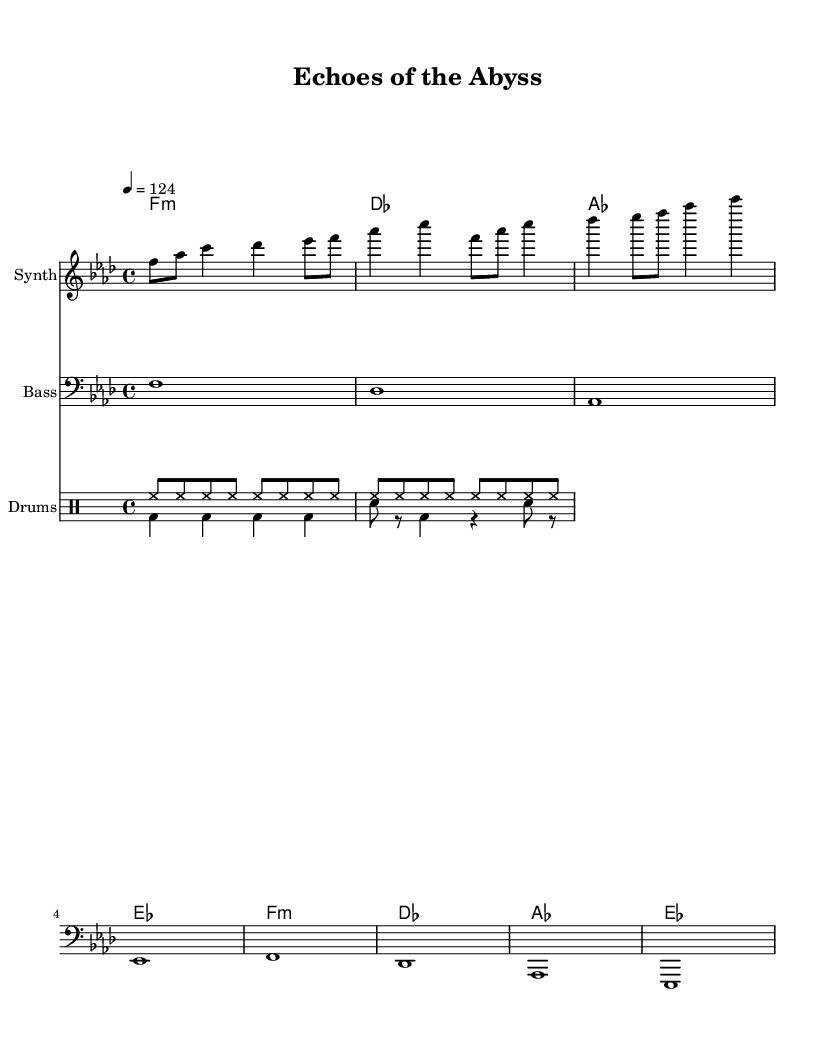What is the key signature of this music? The key signature is indicated by the notes shown at the beginning of the staff. In this case, it shows four flats, which corresponds to F minor.
Answer: F minor What is the tempo marking of this piece? The tempo is indicated at the beginning of the score as "4 = 124", which means that the quarter note gets a tempo of 124 beats per minute.
Answer: 124 How many measures are in the melody section? The melody section consists of two identical lines, each containing four beats. Therefore, there are two measures in total.
Answer: 2 What chord is played in the first measure? The first measure of the harmony shows F minor chord which is represented using the appropriate chord symbols.
Answer: F minor What rhythmic pattern is used for the hi-hat in the drum section? The hi-hat pattern is indicated in the drum section and consists of continuous eighth notes throughout the two measures.
Answer: Eighth notes How many different instruments are represented in the score? The score shows three distinct parts: the synth for the melody, the bass, and the drums. Altogether, this gives us three separate instruments.
Answer: 3 What type of sound or vibe does the title suggest for this track? The title "Echoes of the Abyss" suggests an atmospheric and immersive sound, likely evoking feelings related to underwater exploration, which aligns well with the deep house genre.
Answer: Atmospheric 